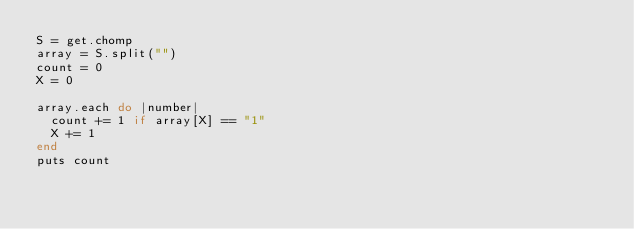<code> <loc_0><loc_0><loc_500><loc_500><_Ruby_>S = get.chomp
array = S.split("")
count = 0
X = 0

array.each do |number|
  count += 1 if array[X] == "1"
  X += 1
end
puts count
</code> 